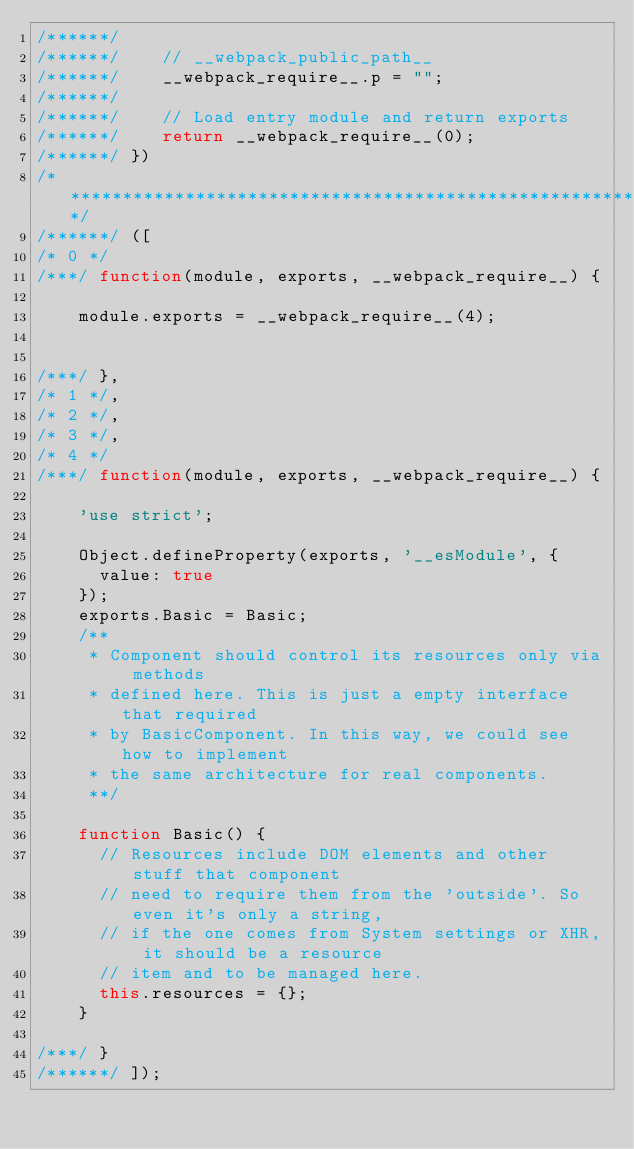<code> <loc_0><loc_0><loc_500><loc_500><_JavaScript_>/******/
/******/ 	// __webpack_public_path__
/******/ 	__webpack_require__.p = "";
/******/
/******/ 	// Load entry module and return exports
/******/ 	return __webpack_require__(0);
/******/ })
/************************************************************************/
/******/ ([
/* 0 */
/***/ function(module, exports, __webpack_require__) {

	module.exports = __webpack_require__(4);


/***/ },
/* 1 */,
/* 2 */,
/* 3 */,
/* 4 */
/***/ function(module, exports, __webpack_require__) {

	'use strict';
	
	Object.defineProperty(exports, '__esModule', {
	  value: true
	});
	exports.Basic = Basic;
	/**
	 * Component should control its resources only via methods
	 * defined here. This is just a empty interface that required
	 * by BasicComponent. In this way, we could see how to implement
	 * the same architecture for real components.
	 **/
	
	function Basic() {
	  // Resources include DOM elements and other stuff that component
	  // need to require them from the 'outside'. So even it's only a string,
	  // if the one comes from System settings or XHR, it should be a resource
	  // item and to be managed here.
	  this.resources = {};
	}

/***/ }
/******/ ]);</code> 